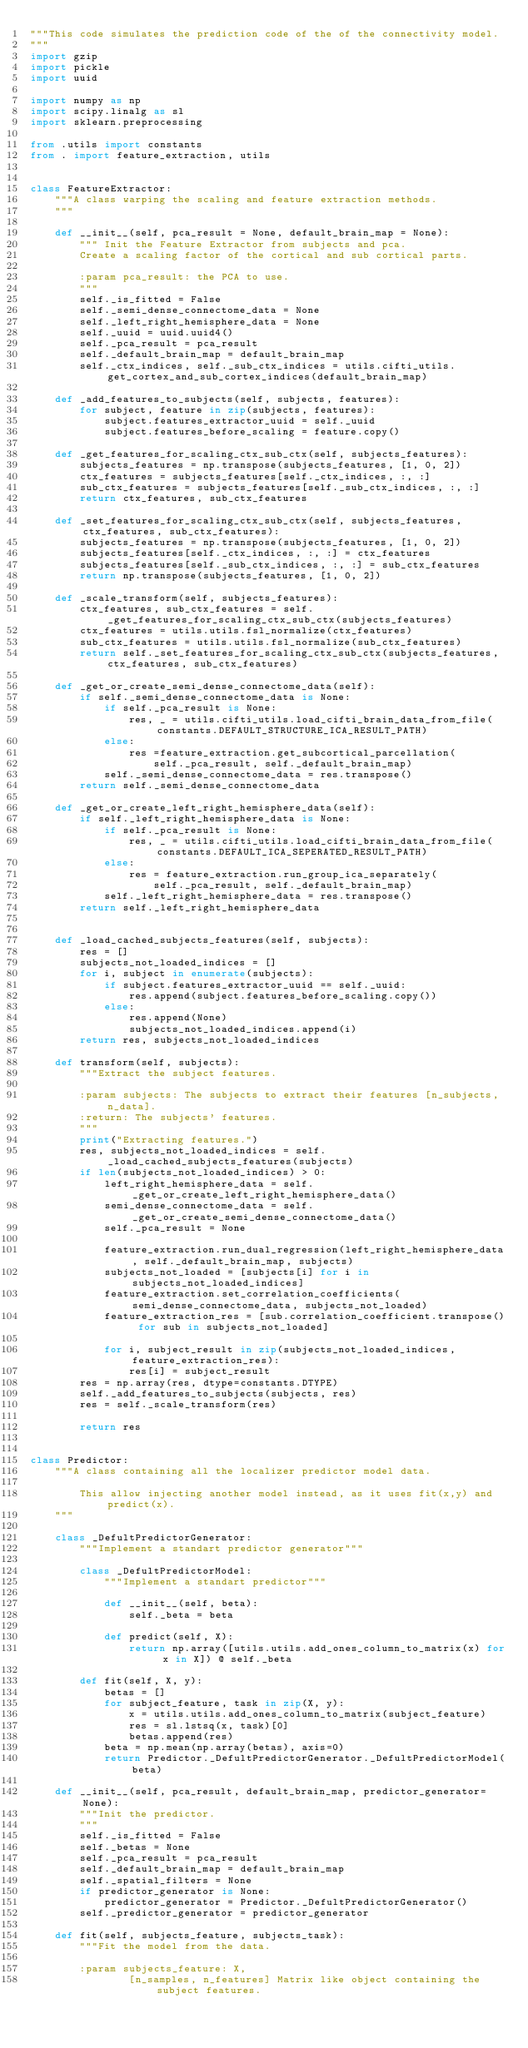<code> <loc_0><loc_0><loc_500><loc_500><_Python_>"""This code simulates the prediction code of the of the connectivity model.
"""
import gzip
import pickle
import uuid

import numpy as np
import scipy.linalg as sl
import sklearn.preprocessing

from .utils import constants
from . import feature_extraction, utils


class FeatureExtractor:
	"""A class warping the scaling and feature extraction methods.
	"""

	def __init__(self, pca_result = None, default_brain_map = None):
		""" Init the Feature Extractor from subjects and pca.
		Create a scaling factor of the cortical and sub cortical parts.

		:param pca_result: the PCA to use.
		"""
		self._is_fitted = False
		self._semi_dense_connectome_data = None
		self._left_right_hemisphere_data = None
		self._uuid = uuid.uuid4()
		self._pca_result = pca_result
		self._default_brain_map = default_brain_map
		self._ctx_indices, self._sub_ctx_indices = utils.cifti_utils.get_cortex_and_sub_cortex_indices(default_brain_map)

	def _add_features_to_subjects(self, subjects, features):
		for subject, feature in zip(subjects, features):
			subject.features_extractor_uuid = self._uuid
			subject.features_before_scaling = feature.copy()

	def _get_features_for_scaling_ctx_sub_ctx(self, subjects_features):
		subjects_features = np.transpose(subjects_features, [1, 0, 2])
		ctx_features = subjects_features[self._ctx_indices, :, :]
		sub_ctx_features = subjects_features[self._sub_ctx_indices, :, :]
		return ctx_features, sub_ctx_features

	def _set_features_for_scaling_ctx_sub_ctx(self, subjects_features, ctx_features, sub_ctx_features):
		subjects_features = np.transpose(subjects_features, [1, 0, 2])
		subjects_features[self._ctx_indices, :, :] = ctx_features
		subjects_features[self._sub_ctx_indices, :, :] = sub_ctx_features
		return np.transpose(subjects_features, [1, 0, 2])

	def _scale_transform(self, subjects_features):
		ctx_features, sub_ctx_features = self._get_features_for_scaling_ctx_sub_ctx(subjects_features)
		ctx_features = utils.utils.fsl_normalize(ctx_features)
		sub_ctx_features = utils.utils.fsl_normalize(sub_ctx_features)
		return self._set_features_for_scaling_ctx_sub_ctx(subjects_features, ctx_features, sub_ctx_features)

	def _get_or_create_semi_dense_connectome_data(self):
		if self._semi_dense_connectome_data is None:
			if self._pca_result is None:
				res, _ = utils.cifti_utils.load_cifti_brain_data_from_file(constants.DEFAULT_STRUCTURE_ICA_RESULT_PATH)
			else:
				res =feature_extraction.get_subcortical_parcellation(
					self._pca_result, self._default_brain_map)
			self._semi_dense_connectome_data = res.transpose()
		return self._semi_dense_connectome_data

	def _get_or_create_left_right_hemisphere_data(self):
		if self._left_right_hemisphere_data is None:
			if self._pca_result is None:
				res, _ = utils.cifti_utils.load_cifti_brain_data_from_file(constants.DEFAULT_ICA_SEPERATED_RESULT_PATH)
			else:
				res = feature_extraction.run_group_ica_separately(
					self._pca_result, self._default_brain_map)
			self._left_right_hemisphere_data = res.transpose()
		return self._left_right_hemisphere_data


	def _load_cached_subjects_features(self, subjects):
		res = []
		subjects_not_loaded_indices = []
		for i, subject in enumerate(subjects):
			if subject.features_extractor_uuid == self._uuid:
				res.append(subject.features_before_scaling.copy())
			else:
				res.append(None)
				subjects_not_loaded_indices.append(i)
		return res, subjects_not_loaded_indices

	def transform(self, subjects):
		"""Extract the subject features.

		:param subjects: The subjects to extract their features [n_subjects, n_data].
		:return: The subjects' features.
		"""
		print("Extracting features.")
		res, subjects_not_loaded_indices = self._load_cached_subjects_features(subjects)
		if len(subjects_not_loaded_indices) > 0:
			left_right_hemisphere_data = self._get_or_create_left_right_hemisphere_data()
			semi_dense_connectome_data = self._get_or_create_semi_dense_connectome_data()
			self._pca_result = None
			
			feature_extraction.run_dual_regression(left_right_hemisphere_data, self._default_brain_map, subjects)
			subjects_not_loaded = [subjects[i] for i in subjects_not_loaded_indices]
			feature_extraction.set_correlation_coefficients(semi_dense_connectome_data, subjects_not_loaded)
			feature_extraction_res = [sub.correlation_coefficient.transpose() for sub in subjects_not_loaded]

			for i, subject_result in zip(subjects_not_loaded_indices, feature_extraction_res):
				res[i] = subject_result
		res = np.array(res, dtype=constants.DTYPE)
		self._add_features_to_subjects(subjects, res)
		res = self._scale_transform(res)

		return res


class Predictor:
	"""A class containing all the localizer predictor model data.

		This allow injecting another model instead, as it uses fit(x,y) and predict(x).
	"""
	
	class _DefultPredictorGenerator:
		"""Implement a standart predictor generator"""
		
		class _DefultPredictorModel:
			"""Implement a standart predictor"""
			
			def __init__(self, beta):
				self._beta = beta
			
			def predict(self, X):
				return np.array([utils.utils.add_ones_column_to_matrix(x) for x in X]) @ self._beta

		def fit(self, X, y):
			betas = []
			for subject_feature, task in zip(X, y):
				x = utils.utils.add_ones_column_to_matrix(subject_feature)
				res = sl.lstsq(x, task)[0]
				betas.append(res)
			beta = np.mean(np.array(betas), axis=0)
			return Predictor._DefultPredictorGenerator._DefultPredictorModel(beta)
			
	def __init__(self, pca_result, default_brain_map, predictor_generator=None):
		"""Init the predictor.
		"""
		self._is_fitted = False
		self._betas = None
		self._pca_result = pca_result
		self._default_brain_map = default_brain_map
		self._spatial_filters = None
		if predictor_generator is None:
			predictor_generator = Predictor._DefultPredictorGenerator()
		self._predictor_generator = predictor_generator

	def fit(self, subjects_feature, subjects_task):
		"""Fit the model from the data.

		:param subjects_feature: X,
				[n_samples, n_features] Matrix like object containing the subject features.</code> 